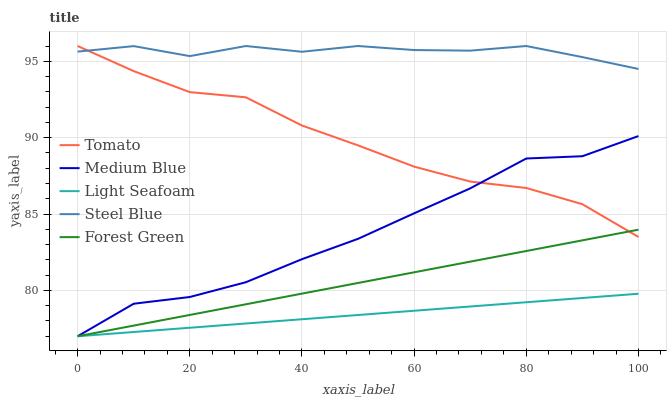Does Light Seafoam have the minimum area under the curve?
Answer yes or no. Yes. Does Steel Blue have the maximum area under the curve?
Answer yes or no. Yes. Does Forest Green have the minimum area under the curve?
Answer yes or no. No. Does Forest Green have the maximum area under the curve?
Answer yes or no. No. Is Light Seafoam the smoothest?
Answer yes or no. Yes. Is Medium Blue the roughest?
Answer yes or no. Yes. Is Forest Green the smoothest?
Answer yes or no. No. Is Forest Green the roughest?
Answer yes or no. No. Does Forest Green have the lowest value?
Answer yes or no. Yes. Does Steel Blue have the lowest value?
Answer yes or no. No. Does Steel Blue have the highest value?
Answer yes or no. Yes. Does Forest Green have the highest value?
Answer yes or no. No. Is Light Seafoam less than Tomato?
Answer yes or no. Yes. Is Steel Blue greater than Forest Green?
Answer yes or no. Yes. Does Forest Green intersect Tomato?
Answer yes or no. Yes. Is Forest Green less than Tomato?
Answer yes or no. No. Is Forest Green greater than Tomato?
Answer yes or no. No. Does Light Seafoam intersect Tomato?
Answer yes or no. No. 